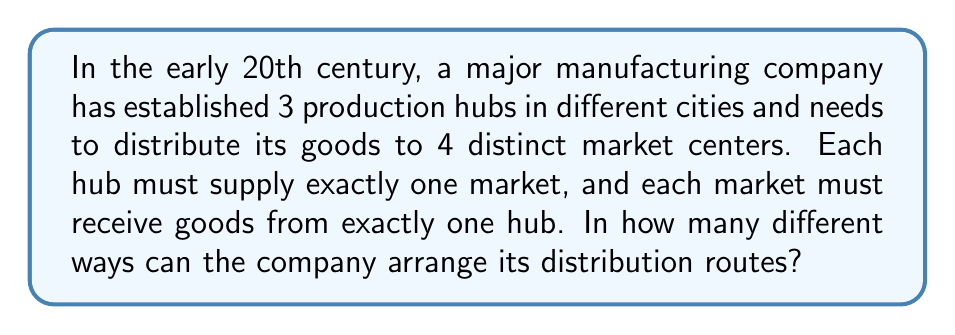Can you answer this question? To solve this problem, we can use the concept of permutations. Here's a step-by-step explanation:

1. We have 3 hubs and 4 markets. This means we need to choose 3 out of 4 markets to receive goods from the hubs.

2. The number of ways to choose 3 markets out of 4 is given by the combination formula:

   $$\binom{4}{3} = \frac{4!}{3!(4-3)!} = \frac{4!}{3!1!} = 4$$

3. Now, for each of these 4 ways of choosing markets, we need to consider how many ways we can assign the 3 hubs to these 3 chosen markets.

4. This is a straightforward permutation of 3 elements, which is calculated as:

   $$3! = 3 \times 2 \times 1 = 6$$

5. By the multiplication principle, the total number of ways to distribute goods is the product of the number of ways to choose the markets and the number of ways to assign hubs to those markets:

   $$4 \times 6 = 24$$

Therefore, there are 24 different possible routes for distributing goods between the manufacturing hubs and markets.
Answer: 24 